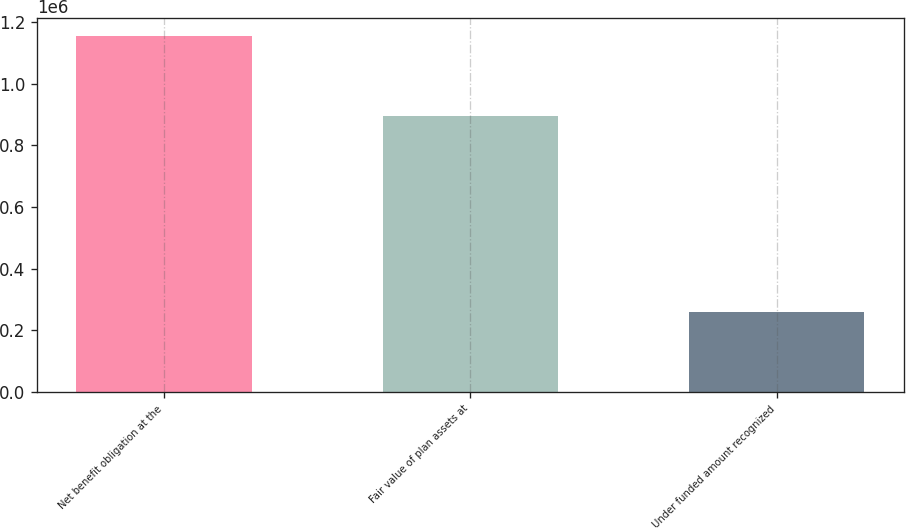Convert chart to OTSL. <chart><loc_0><loc_0><loc_500><loc_500><bar_chart><fcel>Net benefit obligation at the<fcel>Fair value of plan assets at<fcel>Under funded amount recognized<nl><fcel>1.15559e+06<fcel>896298<fcel>259294<nl></chart> 